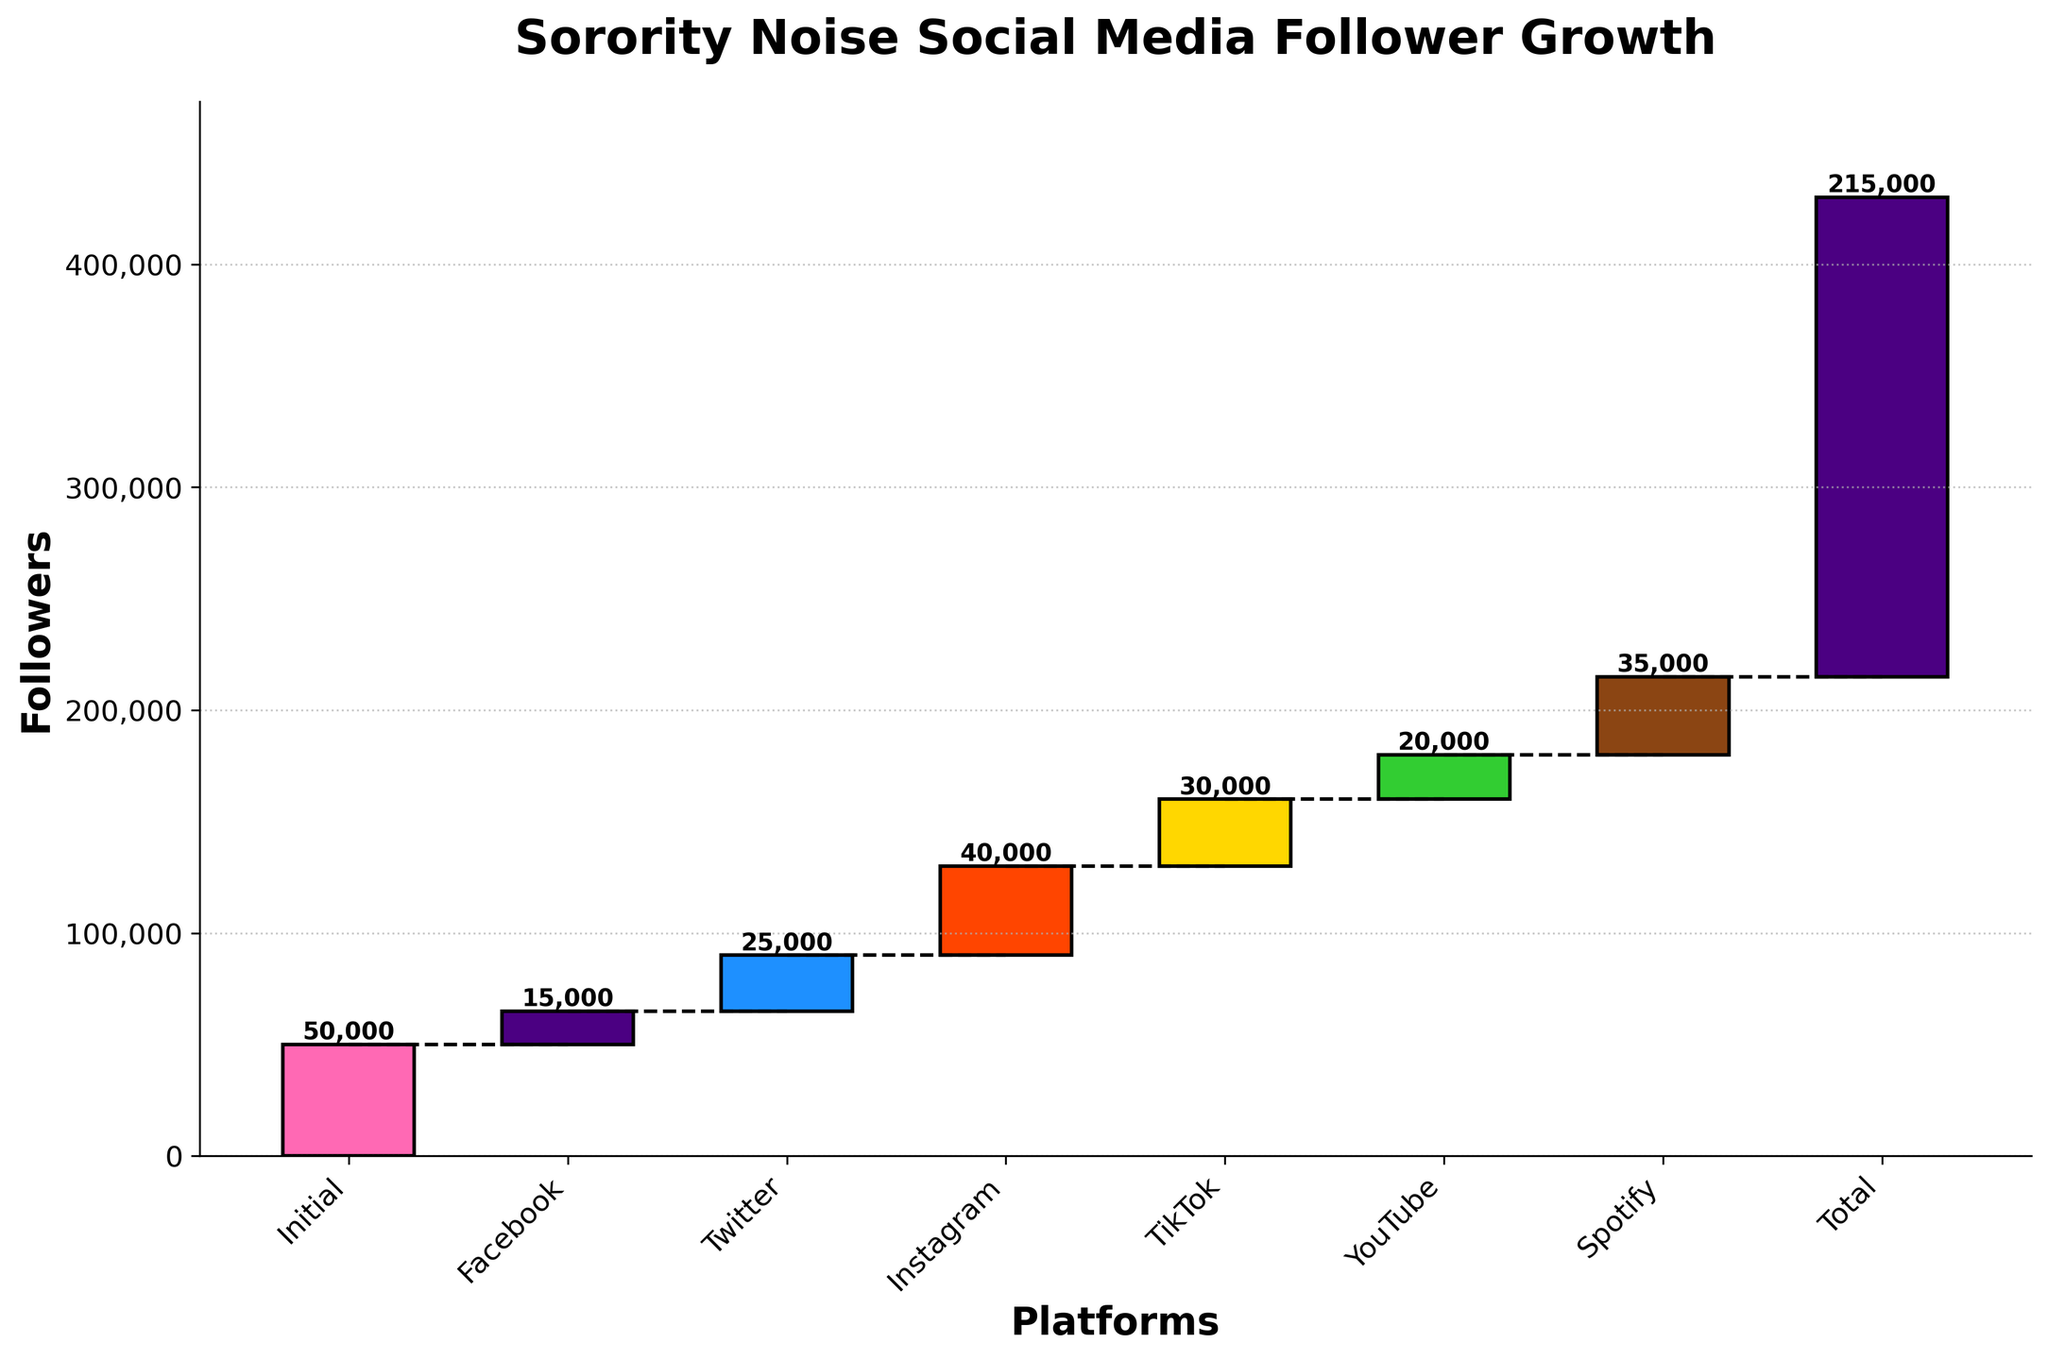What's the title of the chart? The title is directly stated at the top of the chart.
Answer: Sorority Noise Social Media Follower Growth Which platform contributed the most followers? Looking at the heights of the bars, the Instagram bar is the tallest.
Answer: Instagram How many followers did Sorority Noise have initially? The initial number of followers is represented by the first bar labeled "Initial."
Answer: 50,000 What is the cumulative number of followers after adding TikTok? The cumulative number is acquired by adding followers from Initial, Facebook, Twitter, Instagram, and TikTok. From the chart, the values are 50,000 + 15,000 + 25,000 + 40,000 + 30,000 = 160,000
Answer: 160,000 What is the percentage increase in followers from Initial to Total? Calculate the percentage increase using (Final - Initial) / Initial * 100. This gives (215,000 - 50,000) / 50,000 * 100 = 330%
Answer: 330% Which platform contributed fewer followers, Facebook or YouTube? By comparing the heights of the bars for Facebook and YouTube, the Facebook bar is shorter.
Answer: Facebook What is the combined total of followers contributed by TikTok and Spotify? Adding the values for TikTok and Spotify: 30,000 + 35,000 = 65,000
Answer: 65,000 What is the difference in followers between Twitter and YouTube? Subtract the number of YouTube followers from Twitter followers: 25,000 - 20,000 = 5,000
Answer: 5,000 What is the average number of followers contributed by Facebook, Twitter, and Instagram? The average is calculated by summing the followers from these platforms and dividing by 3: (15,000 + 25,000 + 40,000) / 3 = 26,667
Answer: 26,667 